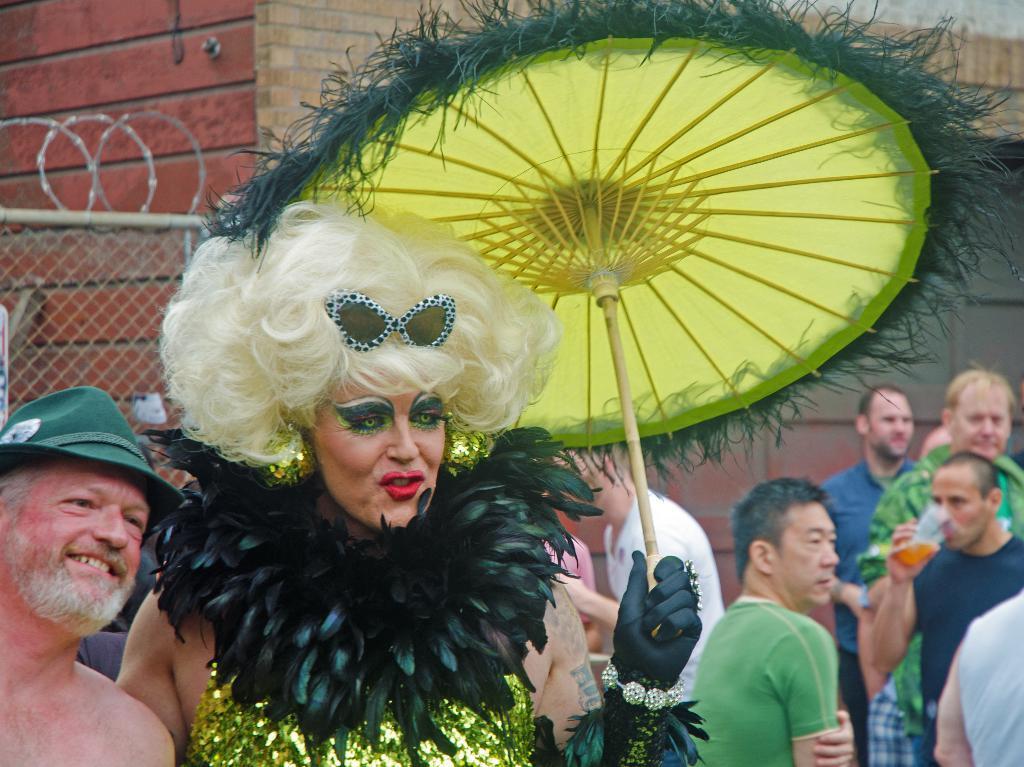Can you describe this image briefly? At the bottom of the image few people are standing and holding something. Behind them there is wall. 